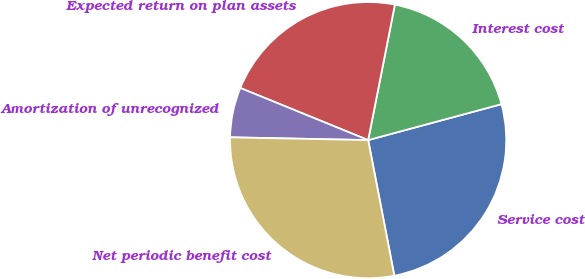<chart> <loc_0><loc_0><loc_500><loc_500><pie_chart><fcel>Service cost<fcel>Interest cost<fcel>Expected return on plan assets<fcel>Amortization of unrecognized<fcel>Net periodic benefit cost<nl><fcel>26.16%<fcel>17.71%<fcel>21.94%<fcel>5.84%<fcel>28.36%<nl></chart> 